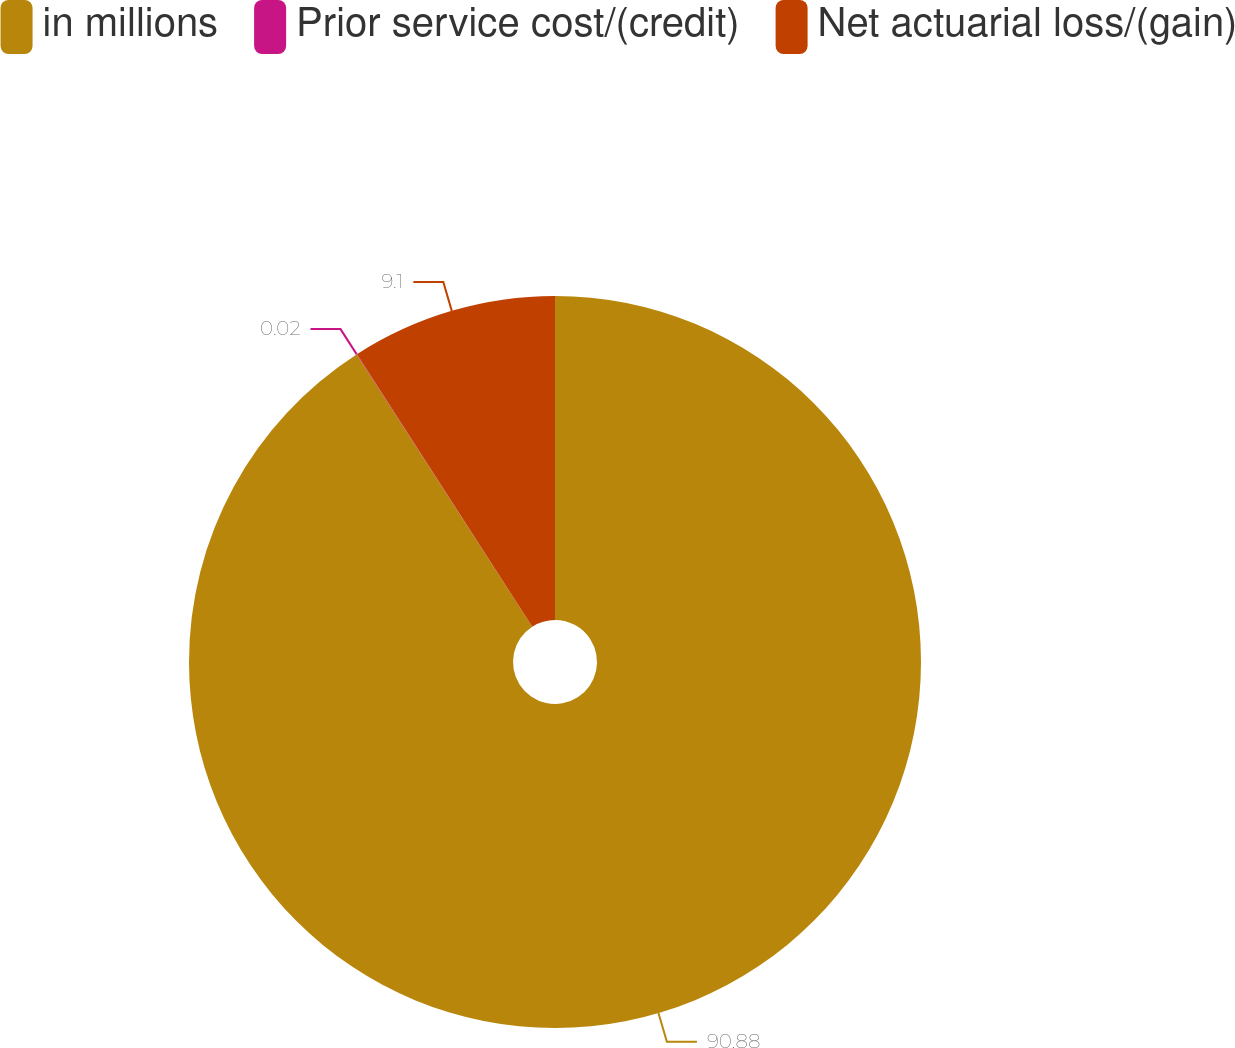<chart> <loc_0><loc_0><loc_500><loc_500><pie_chart><fcel>in millions<fcel>Prior service cost/(credit)<fcel>Net actuarial loss/(gain)<nl><fcel>90.88%<fcel>0.02%<fcel>9.1%<nl></chart> 